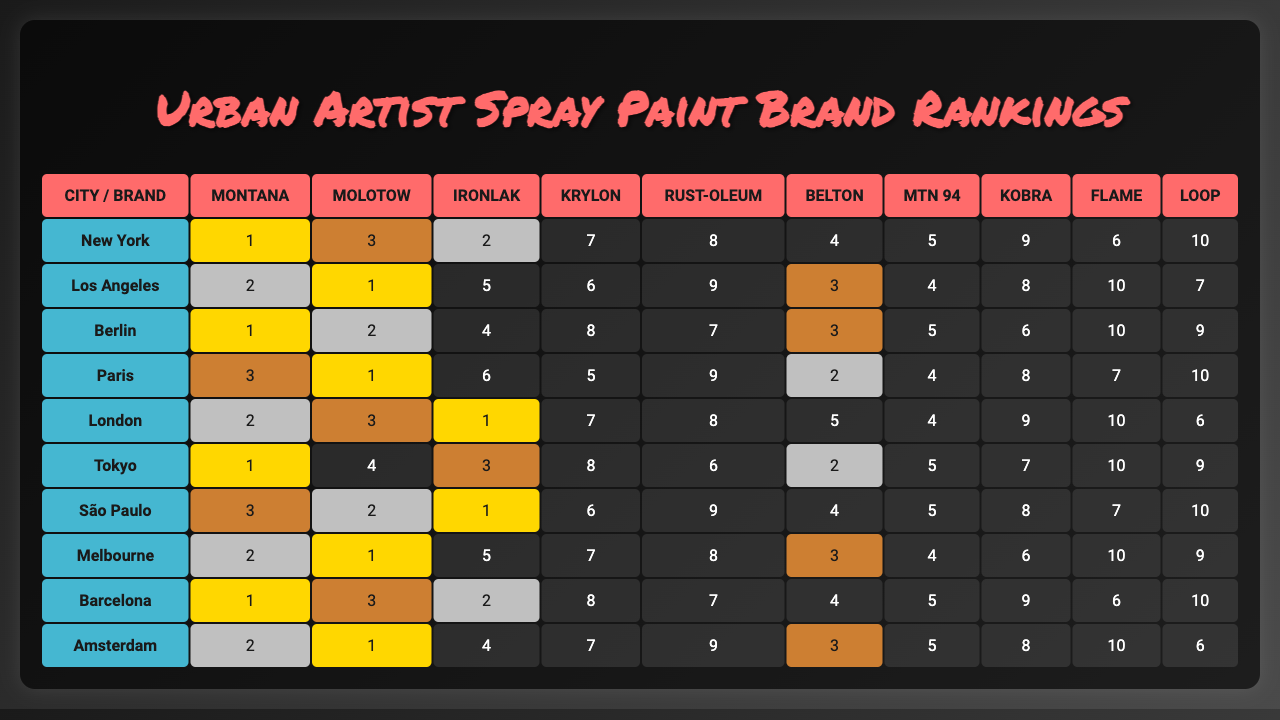What is the highest-ranking spray paint brand in New York? In the New York row of the table, the ranking shows that Montana has the rank of 1, which is the highest.
Answer: Montana Which brand is ranked 3rd in Berlin? Looking at the Berlin row, the brand that has the ranking of 3rd is Ironlak.
Answer: Ironlak How many brands are ranked in the top 5 in Tokyo? In the Tokyo row, the brands ranked 1 to 5 are Montana (1), Molotow (4), Ironlak (3), Krylon (8), and Rust-Oleum (6). Thus, there are 4 brands ranked in the top 5.
Answer: 4 In which city is Kobra ranked highest? Reviewing Kobra's rankings across all cities, Kobra is ranked 5th in New York, 7th in Los Angeles, and 4th in Melbourne, which is the highest ranking in these cities.
Answer: Melbourne What is the average ranking of Rust-Oleum across all cities? The rankings for Rust-Oleum across the cities are: 8 (New York), 9 (Los Angeles), 7 (Berlin), 9 (Paris), 8 (London), 6 (Tokyo), 9 (São Paulo), 8 (Melbourne), 7 (Barcelona), and 9 (Amsterdam). Adding these up gives a total of 81 and dividing by 10 gives an average of 8.1.
Answer: 8.1 Is Ironlak the top-rated brand in any city? Checking the table, Ironlak ranks 1st in both New York and Berlin, confirming that Ironlak is indeed the top-rated brand in these cities.
Answer: Yes Which city has the most consistent top-ranking brands (ranked 1 or 2)? Evaluating the cities, we see that New York has Montana (1) and Ironlak (2), Los Angeles has Molotow (1) and others, Berlin has Montana (1), Paris has Krylon (1). Counting the total occurrences reveals Los Angeles with 2 occurrences of ranks 1 or 2, while other cities are also consistent. The highest among them is Los Angeles.
Answer: Los Angeles What is the ranking difference between the highest and lowest brand in Barcelona? For Barcelona, the rankings show a highest rank of 2 (Ironlak) and a lowest rank of 10 (Loop). The difference is 10 - 2 = 8.
Answer: 8 Which brand has the most variability in rankings across different cities? By analyzing the table, we look at the highest and lowest rankings for each brand. For instance, Loop ranks from 7th to 10th, while Molotow ranks from 1st to 10th. The rankings for Molotow fluctuate more compared to Loop, making it the most variable.
Answer: Molotow Is there a city where all brands are ranked 5 or higher? Checking the rankings for each city reveals that there are cities where at least one brand is ranked below 5. For example, Amsterdam has two brands below 5, indicating that there is no city where all brands are ranked 5 or higher.
Answer: No 